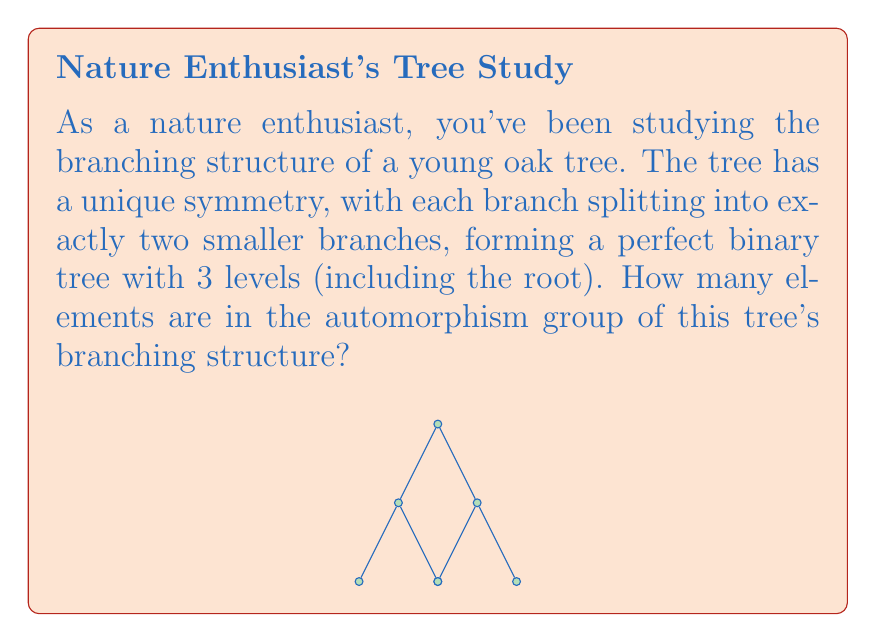Give your solution to this math problem. Let's approach this step-by-step:

1) First, we need to understand what an automorphism of a tree is. It's a bijective mapping of the tree to itself that preserves the structure (i.e., adjacency relationships).

2) In a binary tree, for each non-leaf node, an automorphism can either:
   a) Keep the left and right subtrees in their original positions, or
   b) Swap the left and right subtrees

3) Let's count the number of decisions we can make at each level:
   - Level 0 (root): 1 choice (we can't change anything here)
   - Level 1: 2 choices (swap or don't swap the two subtrees)
   - Level 2: 4 choices (for each of the two nodes at level 1, we can independently decide to swap or not swap their children)

4) The total number of automorphisms is the product of the number of choices at each level:

   $$ 1 \times 2 \times 2^2 = 8 $$

5) This result can also be derived from the general formula for the number of automorphisms in a perfect binary tree with $n$ levels:

   $$ |\text{Aut}(T)| = 2^{1 + 2 + ... + (n-1)} = 2^{\frac{n(n-1)}{2}} $$

   For $n = 3$, we get:
   $$ 2^{\frac{3(3-1)}{2}} = 2^3 = 8 $$

Thus, there are 8 elements in the automorphism group of this tree's branching structure.
Answer: 8 